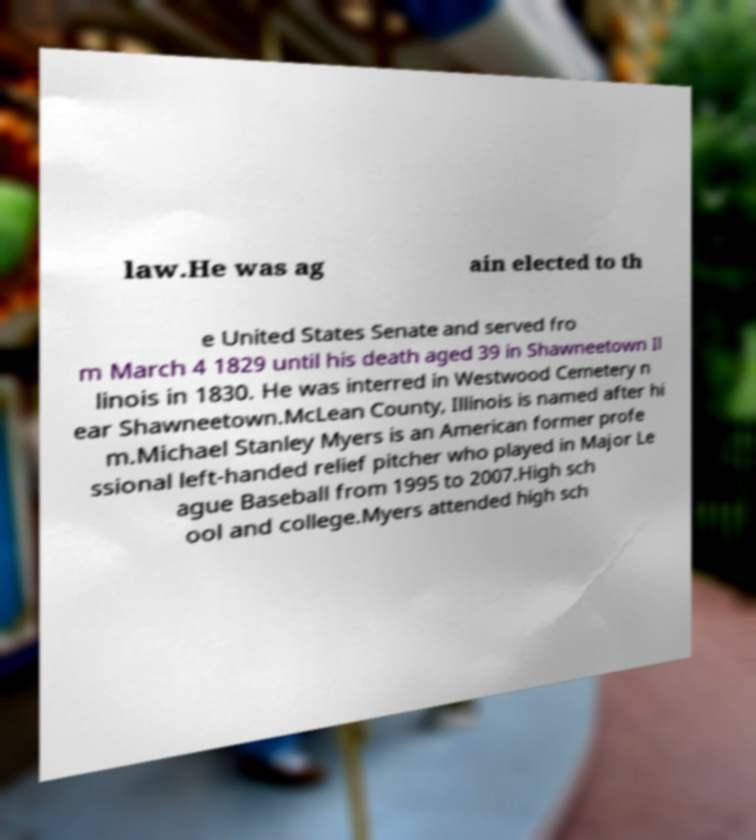There's text embedded in this image that I need extracted. Can you transcribe it verbatim? law.He was ag ain elected to th e United States Senate and served fro m March 4 1829 until his death aged 39 in Shawneetown Il linois in 1830. He was interred in Westwood Cemetery n ear Shawneetown.McLean County, Illinois is named after hi m.Michael Stanley Myers is an American former profe ssional left-handed relief pitcher who played in Major Le ague Baseball from 1995 to 2007.High sch ool and college.Myers attended high sch 